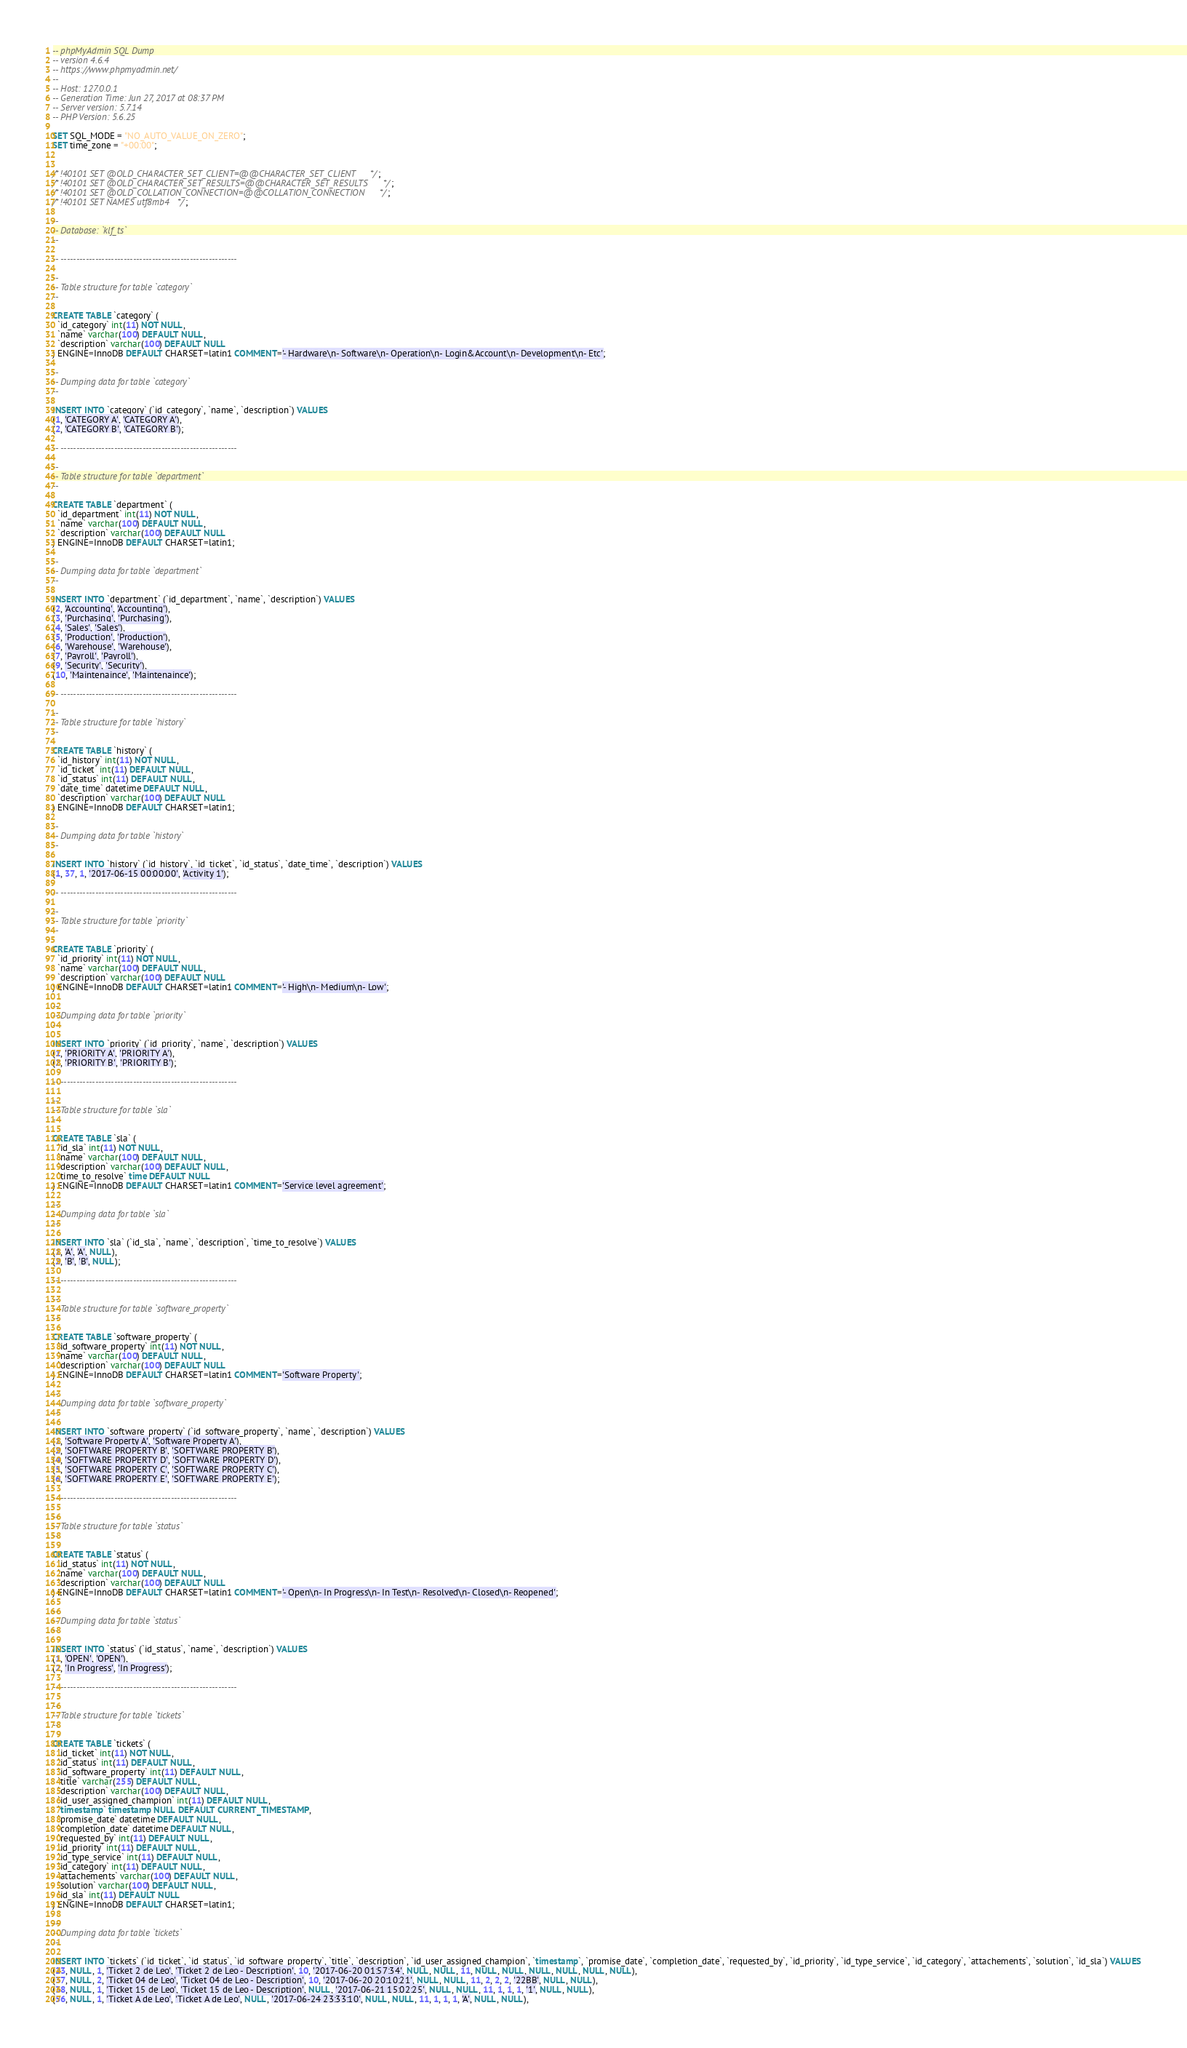<code> <loc_0><loc_0><loc_500><loc_500><_SQL_>-- phpMyAdmin SQL Dump
-- version 4.6.4
-- https://www.phpmyadmin.net/
--
-- Host: 127.0.0.1
-- Generation Time: Jun 27, 2017 at 08:37 PM
-- Server version: 5.7.14
-- PHP Version: 5.6.25

SET SQL_MODE = "NO_AUTO_VALUE_ON_ZERO";
SET time_zone = "+00:00";


/*!40101 SET @OLD_CHARACTER_SET_CLIENT=@@CHARACTER_SET_CLIENT */;
/*!40101 SET @OLD_CHARACTER_SET_RESULTS=@@CHARACTER_SET_RESULTS */;
/*!40101 SET @OLD_COLLATION_CONNECTION=@@COLLATION_CONNECTION */;
/*!40101 SET NAMES utf8mb4 */;

--
-- Database: `klf_ts`
--

-- --------------------------------------------------------

--
-- Table structure for table `category`
--

CREATE TABLE `category` (
  `id_category` int(11) NOT NULL,
  `name` varchar(100) DEFAULT NULL,
  `description` varchar(100) DEFAULT NULL
) ENGINE=InnoDB DEFAULT CHARSET=latin1 COMMENT='- Hardware\n- Software\n- Operation\n- Login&Account\n- Development\n- Etc';

--
-- Dumping data for table `category`
--

INSERT INTO `category` (`id_category`, `name`, `description`) VALUES
(1, 'CATEGORY A', 'CATEGORY A'),
(2, 'CATEGORY B', 'CATEGORY B');

-- --------------------------------------------------------

--
-- Table structure for table `department`
--

CREATE TABLE `department` (
  `id_department` int(11) NOT NULL,
  `name` varchar(100) DEFAULT NULL,
  `description` varchar(100) DEFAULT NULL
) ENGINE=InnoDB DEFAULT CHARSET=latin1;

--
-- Dumping data for table `department`
--

INSERT INTO `department` (`id_department`, `name`, `description`) VALUES
(2, 'Accounting', 'Accounting'),
(3, 'Purchasing', 'Purchasing'),
(4, 'Sales', 'Sales'),
(5, 'Production', 'Production'),
(6, 'Warehouse', 'Warehouse'),
(7, 'Payroll', 'Payroll'),
(9, 'Security', 'Security'),
(10, 'Maintenaince', 'Maintenaince');

-- --------------------------------------------------------

--
-- Table structure for table `history`
--

CREATE TABLE `history` (
  `id_history` int(11) NOT NULL,
  `id_ticket` int(11) DEFAULT NULL,
  `id_status` int(11) DEFAULT NULL,
  `date_time` datetime DEFAULT NULL,
  `description` varchar(100) DEFAULT NULL
) ENGINE=InnoDB DEFAULT CHARSET=latin1;

--
-- Dumping data for table `history`
--

INSERT INTO `history` (`id_history`, `id_ticket`, `id_status`, `date_time`, `description`) VALUES
(1, 37, 1, '2017-06-15 00:00:00', 'Activity 1');

-- --------------------------------------------------------

--
-- Table structure for table `priority`
--

CREATE TABLE `priority` (
  `id_priority` int(11) NOT NULL,
  `name` varchar(100) DEFAULT NULL,
  `description` varchar(100) DEFAULT NULL
) ENGINE=InnoDB DEFAULT CHARSET=latin1 COMMENT='- High\n- Medium\n- Low';

--
-- Dumping data for table `priority`
--

INSERT INTO `priority` (`id_priority`, `name`, `description`) VALUES
(1, 'PRIORITY A', 'PRIORITY A'),
(2, 'PRIORITY B', 'PRIORITY B');

-- --------------------------------------------------------

--
-- Table structure for table `sla`
--

CREATE TABLE `sla` (
  `id_sla` int(11) NOT NULL,
  `name` varchar(100) DEFAULT NULL,
  `description` varchar(100) DEFAULT NULL,
  `time_to_resolve` time DEFAULT NULL
) ENGINE=InnoDB DEFAULT CHARSET=latin1 COMMENT='Service level agreement';

--
-- Dumping data for table `sla`
--

INSERT INTO `sla` (`id_sla`, `name`, `description`, `time_to_resolve`) VALUES
(1, 'A', 'A', NULL),
(2, 'B', 'B', NULL);

-- --------------------------------------------------------

--
-- Table structure for table `software_property`
--

CREATE TABLE `software_property` (
  `id_software_property` int(11) NOT NULL,
  `name` varchar(100) DEFAULT NULL,
  `description` varchar(100) DEFAULT NULL
) ENGINE=InnoDB DEFAULT CHARSET=latin1 COMMENT='Software Property';

--
-- Dumping data for table `software_property`
--

INSERT INTO `software_property` (`id_software_property`, `name`, `description`) VALUES
(1, 'Software Property A', 'Software Property A'),
(2, 'SOFTWARE PROPERTY B', 'SOFTWARE PROPERTY B'),
(4, 'SOFTWARE PROPERTY D', 'SOFTWARE PROPERTY D'),
(5, 'SOFTWARE PROPERTY C', 'SOFTWARE PROPERTY C'),
(6, 'SOFTWARE PROPERTY E', 'SOFTWARE PROPERTY E');

-- --------------------------------------------------------

--
-- Table structure for table `status`
--

CREATE TABLE `status` (
  `id_status` int(11) NOT NULL,
  `name` varchar(100) DEFAULT NULL,
  `description` varchar(100) DEFAULT NULL
) ENGINE=InnoDB DEFAULT CHARSET=latin1 COMMENT='- Open\n- In Progress\n- In Test\n- Resolved\n- Closed\n- Reopened';

--
-- Dumping data for table `status`
--

INSERT INTO `status` (`id_status`, `name`, `description`) VALUES
(1, 'OPEN', 'OPEN'),
(2, 'In Progress', 'In Progress');

-- --------------------------------------------------------

--
-- Table structure for table `tickets`
--

CREATE TABLE `tickets` (
  `id_ticket` int(11) NOT NULL,
  `id_status` int(11) DEFAULT NULL,
  `id_software_property` int(11) DEFAULT NULL,
  `title` varchar(255) DEFAULT NULL,
  `description` varchar(100) DEFAULT NULL,
  `id_user_assigned_champion` int(11) DEFAULT NULL,
  `timestamp` timestamp NULL DEFAULT CURRENT_TIMESTAMP,
  `promise_date` datetime DEFAULT NULL,
  `completion_date` datetime DEFAULT NULL,
  `requested_by` int(11) DEFAULT NULL,
  `id_priority` int(11) DEFAULT NULL,
  `id_type_service` int(11) DEFAULT NULL,
  `id_category` int(11) DEFAULT NULL,
  `attachements` varchar(100) DEFAULT NULL,
  `solution` varchar(100) DEFAULT NULL,
  `id_sla` int(11) DEFAULT NULL
) ENGINE=InnoDB DEFAULT CHARSET=latin1;

--
-- Dumping data for table `tickets`
--

INSERT INTO `tickets` (`id_ticket`, `id_status`, `id_software_property`, `title`, `description`, `id_user_assigned_champion`, `timestamp`, `promise_date`, `completion_date`, `requested_by`, `id_priority`, `id_type_service`, `id_category`, `attachements`, `solution`, `id_sla`) VALUES
(23, NULL, 1, 'Ticket 2 de Leo', 'Ticket 2 de Leo - Description', 10, '2017-06-20 01:57:34', NULL, NULL, 11, NULL, NULL, NULL, NULL, NULL, NULL),
(37, NULL, 2, 'Ticket 04 de Leo', 'Ticket 04 de Leo - Description', 10, '2017-06-20 20:10:21', NULL, NULL, 11, 2, 2, 2, '22BB', NULL, NULL),
(38, NULL, 1, 'Ticket 15 de Leo', 'Ticket 15 de Leo - Description', NULL, '2017-06-21 15:02:25', NULL, NULL, 11, 1, 1, 1, '1', NULL, NULL),
(56, NULL, 1, 'Ticket A de Leo', 'Ticket A de Leo', NULL, '2017-06-24 23:33:10', NULL, NULL, 11, 1, 1, 1, 'A', NULL, NULL),</code> 